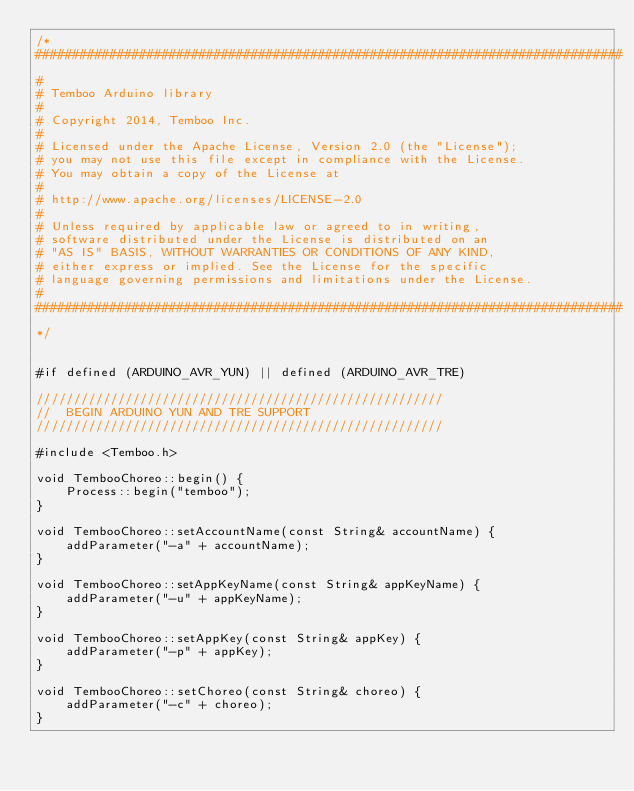Convert code to text. <code><loc_0><loc_0><loc_500><loc_500><_C++_>/*
###############################################################################
#
# Temboo Arduino library
#
# Copyright 2014, Temboo Inc.
# 
# Licensed under the Apache License, Version 2.0 (the "License");
# you may not use this file except in compliance with the License.
# You may obtain a copy of the License at
# 
# http://www.apache.org/licenses/LICENSE-2.0
# 
# Unless required by applicable law or agreed to in writing,
# software distributed under the License is distributed on an
# "AS IS" BASIS, WITHOUT WARRANTIES OR CONDITIONS OF ANY KIND,
# either express or implied. See the License for the specific
# language governing permissions and limitations under the License.
#
###############################################################################
*/


#if defined (ARDUINO_AVR_YUN) || defined (ARDUINO_AVR_TRE)

///////////////////////////////////////////////////////
//  BEGIN ARDUINO YUN AND TRE SUPPORT
///////////////////////////////////////////////////////

#include <Temboo.h>

void TembooChoreo::begin() {
    Process::begin("temboo");
}

void TembooChoreo::setAccountName(const String& accountName) {
    addParameter("-a" + accountName);
}

void TembooChoreo::setAppKeyName(const String& appKeyName) {
    addParameter("-u" + appKeyName);
}

void TembooChoreo::setAppKey(const String& appKey) {
    addParameter("-p" + appKey);
}

void TembooChoreo::setChoreo(const String& choreo) {
    addParameter("-c" + choreo);
}
</code> 